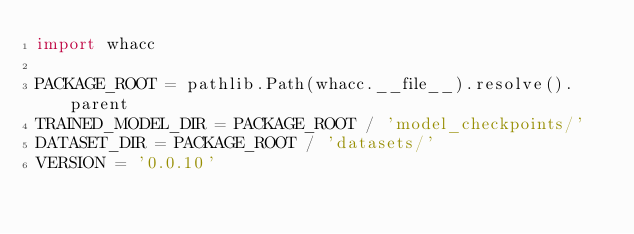<code> <loc_0><loc_0><loc_500><loc_500><_Python_>import whacc

PACKAGE_ROOT = pathlib.Path(whacc.__file__).resolve().parent
TRAINED_MODEL_DIR = PACKAGE_ROOT / 'model_checkpoints/'
DATASET_DIR = PACKAGE_ROOT / 'datasets/'
VERSION = '0.0.10'</code> 